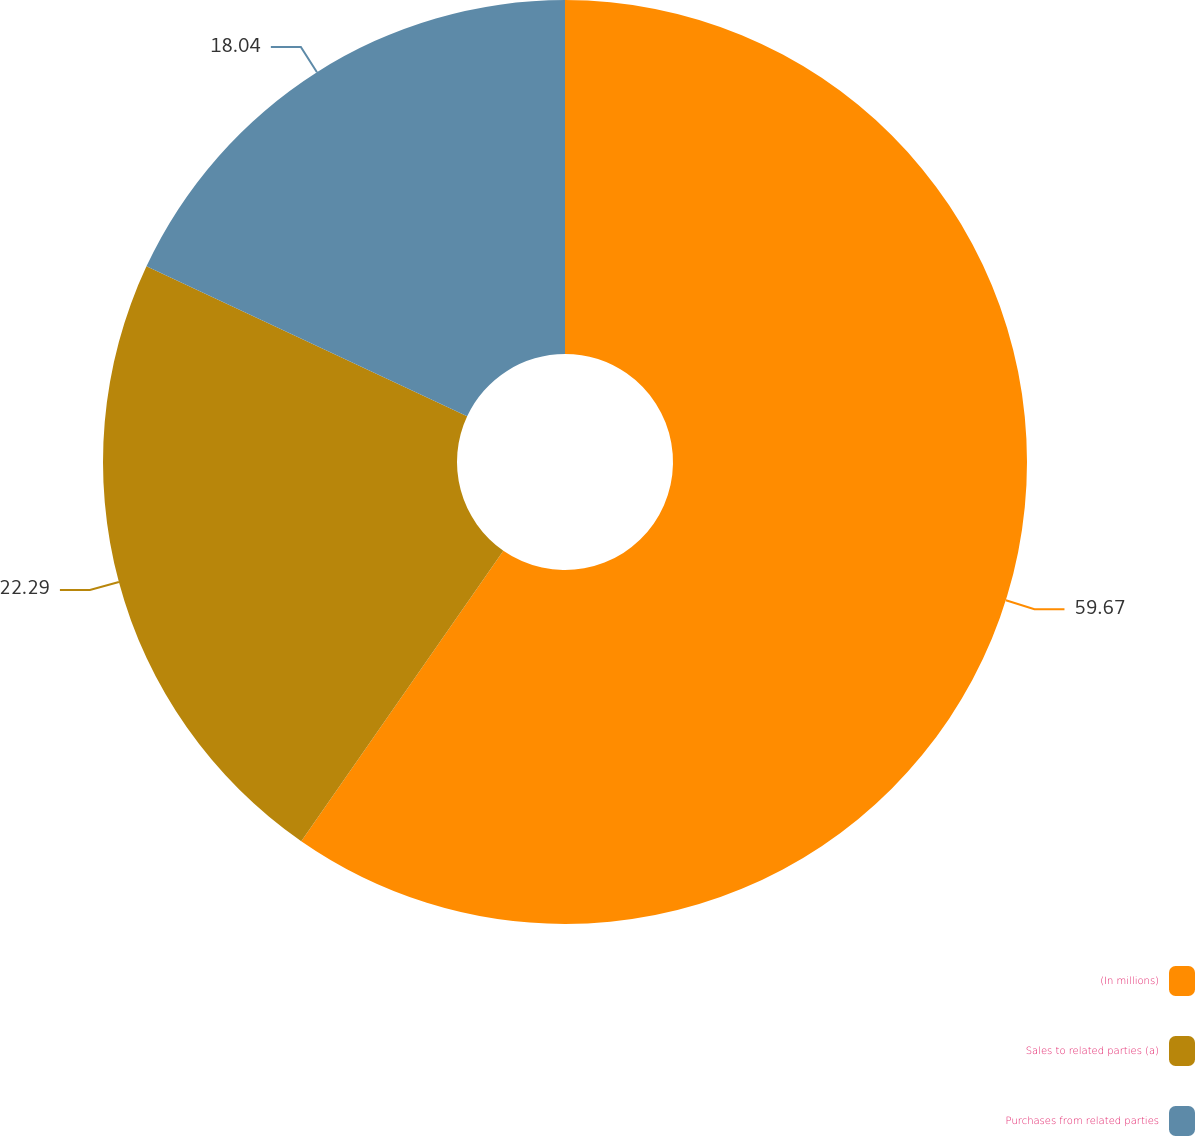<chart> <loc_0><loc_0><loc_500><loc_500><pie_chart><fcel>(In millions)<fcel>Sales to related parties (a)<fcel>Purchases from related parties<nl><fcel>59.67%<fcel>22.29%<fcel>18.04%<nl></chart> 